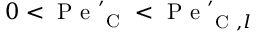<formula> <loc_0><loc_0><loc_500><loc_500>0 < P e _ { C } ^ { \prime } < P e _ { C , l } ^ { \prime }</formula> 